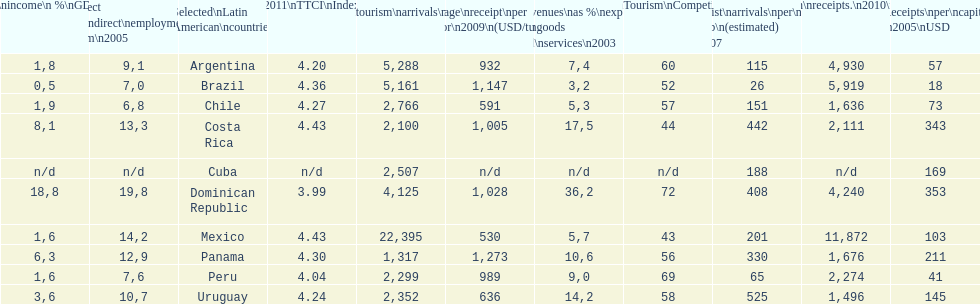What is the name of the country that had the most international tourism arrivals in 2010? Mexico. Parse the full table. {'header': ['Tourism\\nincome\\n\xa0%\\nGDP\\n2003', '% Direct and\\nindirect\\nemployment\\nin tourism\\n2005', 'Selected\\nLatin American\\ncountries', '2011\\nTTCI\\nIndex', 'Internl.\\ntourism\\narrivals\\n2010\\n(x 1000)', 'Average\\nreceipt\\nper visitor\\n2009\\n(USD/turista)', 'Revenues\\nas\xa0%\\nexports of\\ngoods and\\nservices\\n2003', 'World\\nranking\\nTourism\\nCompetitiv.\\nTTCI\\n2011', 'Tourist\\narrivals\\nper\\n1000 inhab\\n(estimated) \\n2007', 'Internl.\\ntourism\\nreceipts.\\n2010\\n(USD\\n(x1000)', 'Receipts\\nper\\ncapita \\n2005\\nUSD'], 'rows': [['1,8', '9,1', 'Argentina', '4.20', '5,288', '932', '7,4', '60', '115', '4,930', '57'], ['0,5', '7,0', 'Brazil', '4.36', '5,161', '1,147', '3,2', '52', '26', '5,919', '18'], ['1,9', '6,8', 'Chile', '4.27', '2,766', '591', '5,3', '57', '151', '1,636', '73'], ['8,1', '13,3', 'Costa Rica', '4.43', '2,100', '1,005', '17,5', '44', '442', '2,111', '343'], ['n/d', 'n/d', 'Cuba', 'n/d', '2,507', 'n/d', 'n/d', 'n/d', '188', 'n/d', '169'], ['18,8', '19,8', 'Dominican Republic', '3.99', '4,125', '1,028', '36,2', '72', '408', '4,240', '353'], ['1,6', '14,2', 'Mexico', '4.43', '22,395', '530', '5,7', '43', '201', '11,872', '103'], ['6,3', '12,9', 'Panama', '4.30', '1,317', '1,273', '10,6', '56', '330', '1,676', '211'], ['1,6', '7,6', 'Peru', '4.04', '2,299', '989', '9,0', '69', '65', '2,274', '41'], ['3,6', '10,7', 'Uruguay', '4.24', '2,352', '636', '14,2', '58', '525', '1,496', '145']]} 